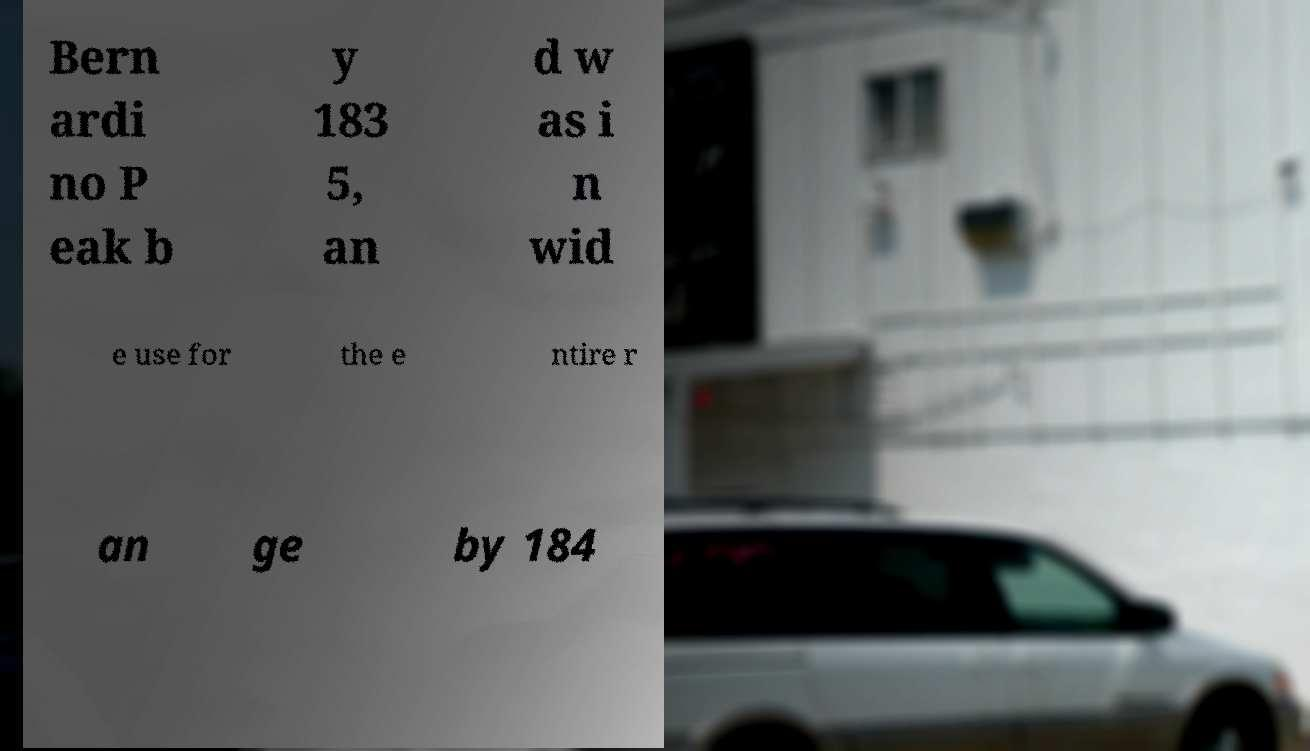Please read and relay the text visible in this image. What does it say? Bern ardi no P eak b y 183 5, an d w as i n wid e use for the e ntire r an ge by 184 